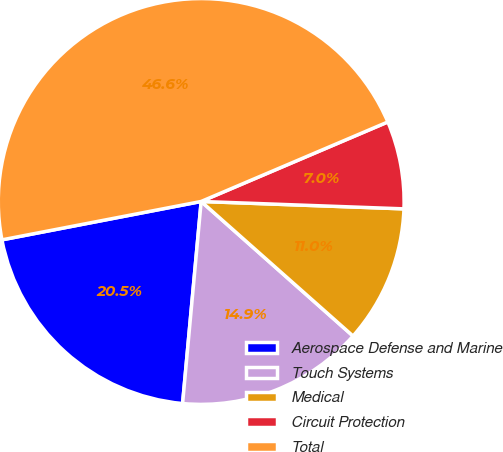Convert chart. <chart><loc_0><loc_0><loc_500><loc_500><pie_chart><fcel>Aerospace Defense and Marine<fcel>Touch Systems<fcel>Medical<fcel>Circuit Protection<fcel>Total<nl><fcel>20.51%<fcel>14.92%<fcel>10.96%<fcel>6.99%<fcel>46.62%<nl></chart> 